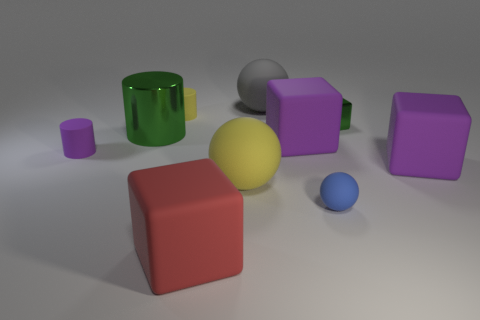There is a yellow rubber thing that is in front of the tiny matte cylinder behind the purple cylinder; how big is it?
Keep it short and to the point. Large. What number of other things are the same color as the metal cube?
Offer a very short reply. 1. What is the material of the tiny blue thing?
Give a very brief answer. Rubber. Is there a thing?
Your response must be concise. Yes. Are there the same number of green cylinders that are to the right of the large gray matte object and cyan metal cylinders?
Offer a very short reply. Yes. Is there anything else that is the same material as the large red thing?
Offer a terse response. Yes. How many tiny objects are brown metallic blocks or yellow rubber balls?
Provide a short and direct response. 0. What is the shape of the small metallic object that is the same color as the large metallic cylinder?
Your answer should be compact. Cube. Is the material of the purple object on the right side of the blue rubber object the same as the gray thing?
Your answer should be compact. Yes. What material is the sphere that is behind the large rubber thing that is right of the small shiny thing?
Offer a terse response. Rubber. 